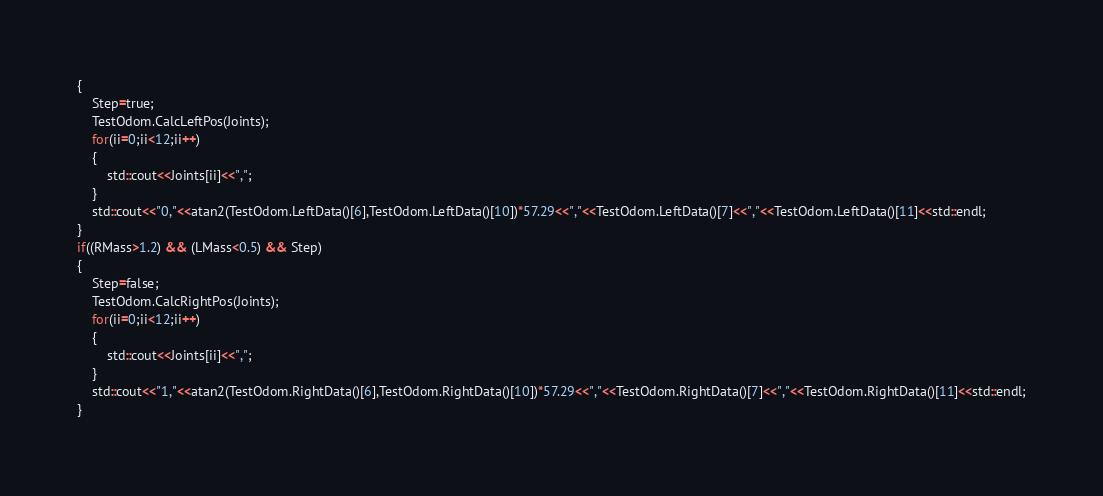Convert code to text. <code><loc_0><loc_0><loc_500><loc_500><_ObjectiveC_>{
	Step=true;
	TestOdom.CalcLeftPos(Joints);
	for(ii=0;ii<12;ii++)
	{
		std::cout<<Joints[ii]<<",";
	}
	std::cout<<"0,"<<atan2(TestOdom.LeftData()[6],TestOdom.LeftData()[10])*57.29<<","<<TestOdom.LeftData()[7]<<","<<TestOdom.LeftData()[11]<<std::endl;
}
if((RMass>1.2) && (LMass<0.5) && Step)
{
	Step=false;
	TestOdom.CalcRightPos(Joints);
	for(ii=0;ii<12;ii++)
	{
		std::cout<<Joints[ii]<<",";
	}
	std::cout<<"1,"<<atan2(TestOdom.RightData()[6],TestOdom.RightData()[10])*57.29<<","<<TestOdom.RightData()[7]<<","<<TestOdom.RightData()[11]<<std::endl;
}
</code> 